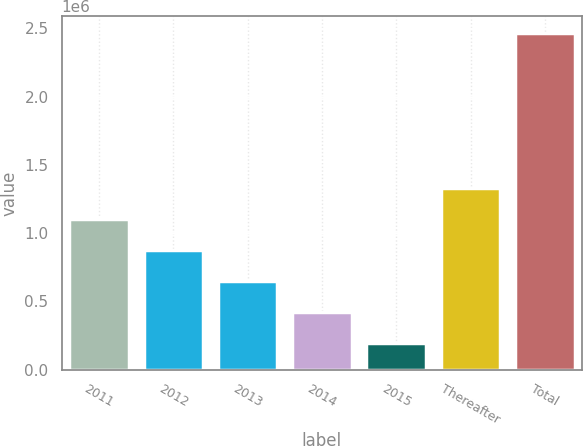Convert chart. <chart><loc_0><loc_0><loc_500><loc_500><bar_chart><fcel>2011<fcel>2012<fcel>2013<fcel>2014<fcel>2015<fcel>Thereafter<fcel>Total<nl><fcel>1.1019e+06<fcel>874632<fcel>647367<fcel>420102<fcel>192837<fcel>1.32916e+06<fcel>2.46549e+06<nl></chart> 